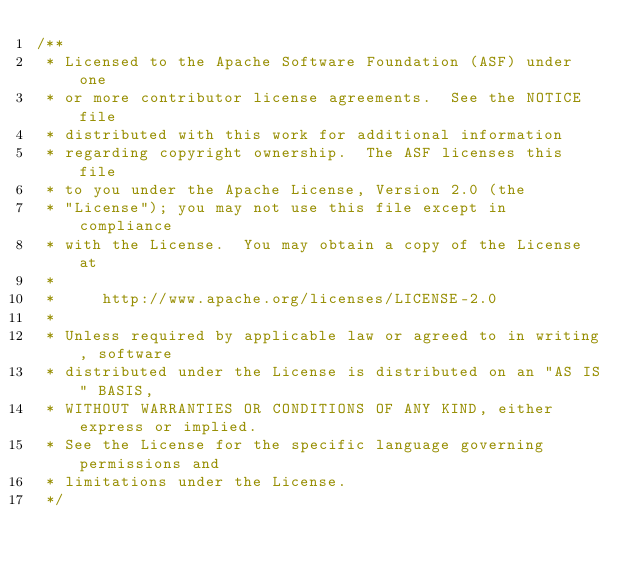Convert code to text. <code><loc_0><loc_0><loc_500><loc_500><_Java_>/**
 * Licensed to the Apache Software Foundation (ASF) under one
 * or more contributor license agreements.  See the NOTICE file
 * distributed with this work for additional information
 * regarding copyright ownership.  The ASF licenses this file
 * to you under the Apache License, Version 2.0 (the
 * "License"); you may not use this file except in compliance
 * with the License.  You may obtain a copy of the License at
 *
 *     http://www.apache.org/licenses/LICENSE-2.0
 *
 * Unless required by applicable law or agreed to in writing, software
 * distributed under the License is distributed on an "AS IS" BASIS,
 * WITHOUT WARRANTIES OR CONDITIONS OF ANY KIND, either express or implied.
 * See the License for the specific language governing permissions and
 * limitations under the License.
 */</code> 